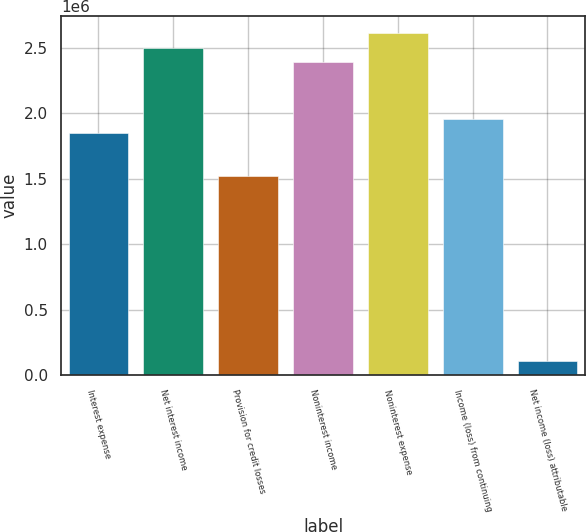<chart> <loc_0><loc_0><loc_500><loc_500><bar_chart><fcel>Interest expense<fcel>Net interest income<fcel>Provision for credit losses<fcel>Noninterest income<fcel>Noninterest expense<fcel>Income (loss) from continuing<fcel>Net income (loss) attributable<nl><fcel>1.84712e+06<fcel>2.49904e+06<fcel>1.52116e+06<fcel>2.39039e+06<fcel>2.6077e+06<fcel>1.95577e+06<fcel>108654<nl></chart> 